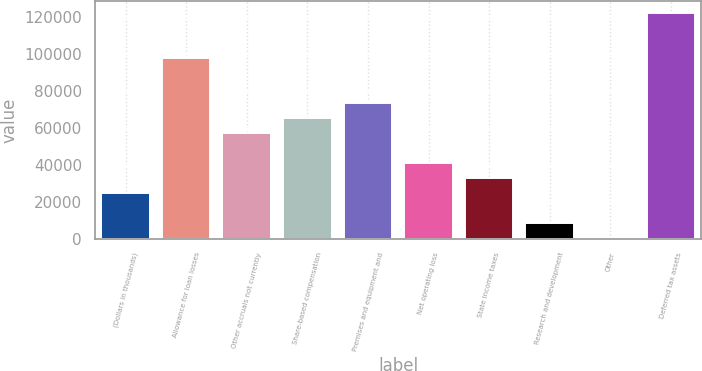<chart> <loc_0><loc_0><loc_500><loc_500><bar_chart><fcel>(Dollars in thousands)<fcel>Allowance for loan losses<fcel>Other accruals not currently<fcel>Share-based compensation<fcel>Premises and equipment and<fcel>Net operating loss<fcel>State income taxes<fcel>Research and development<fcel>Other<fcel>Deferred tax assets<nl><fcel>24480.8<fcel>97908.2<fcel>57115.2<fcel>65273.8<fcel>73432.4<fcel>40798<fcel>32639.4<fcel>8163.6<fcel>5<fcel>122384<nl></chart> 